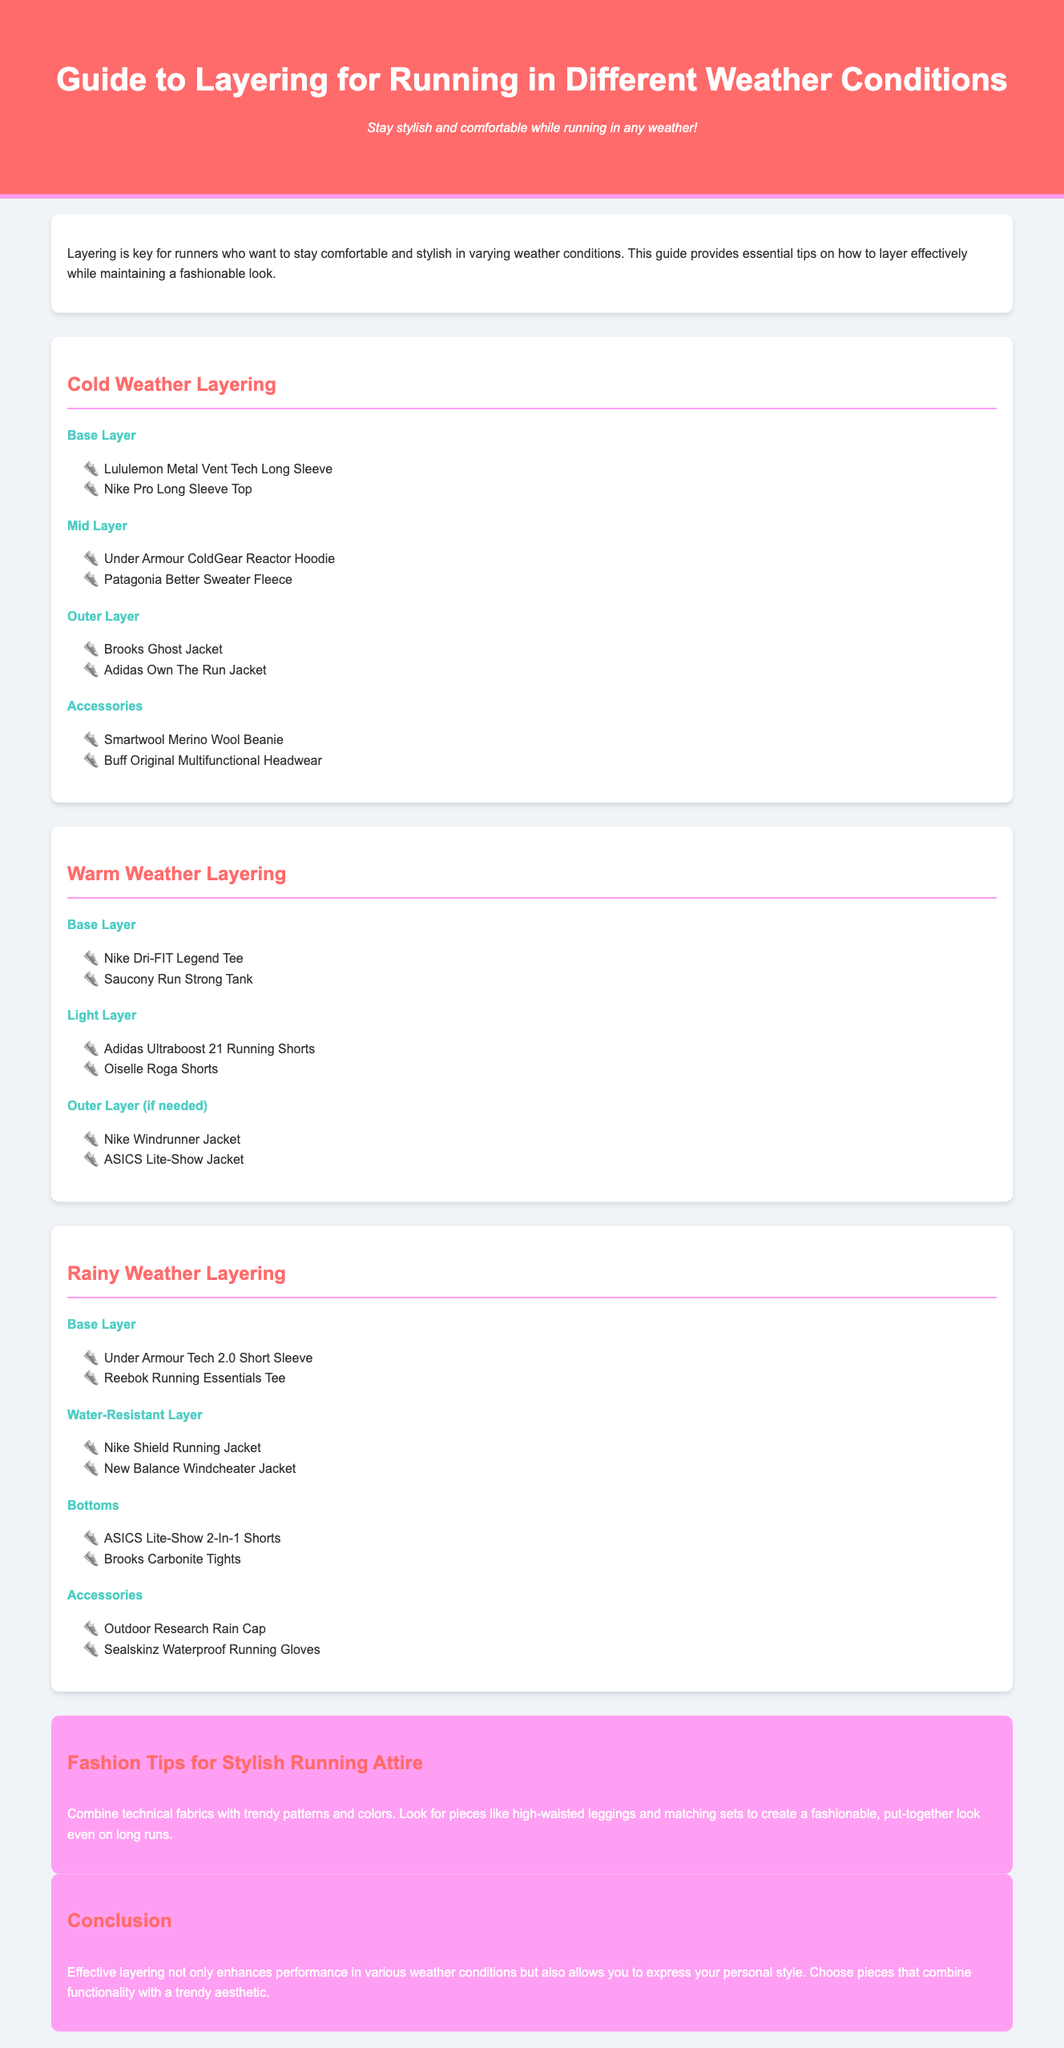what is the title of the guide? The title of the guide is found in the header section of the document.
Answer: Guide to Layering for Running in Different Weather Conditions how many layers are suggested for cold weather? The cold weather section lists four layers, including base, mid, outer, and accessories.
Answer: 4 name one base layer recommended for warm weather. The warm weather section lists two options for base layers; one is specifically asked for.
Answer: Nike Dri-FIT Legend Tee what color is the section header for rainy weather? The rainy weather section header is formatted with a specific color distinct from other sections.
Answer: #ff6b6b which brand's jacket is suggested as an outer layer for rainy weather? The rainy weather outer layer section lists two jackets; one brand is inquired about.
Answer: Nike Shield Running Jacket what is a key fashion tip provided in the document? The document provides fashion tips that advise on combining technical fabrics with trendy designs.
Answer: Combine technical fabrics with trendy patterns and colors how does effective layering benefit runners? The conclusion section explains the advantages of layering for both performance and style.
Answer: Enhances performance and allows personal style expression how many items are listed under accessories for cold weather? The cold weather layering section includes a specific number of accessory items listed.
Answer: 2 